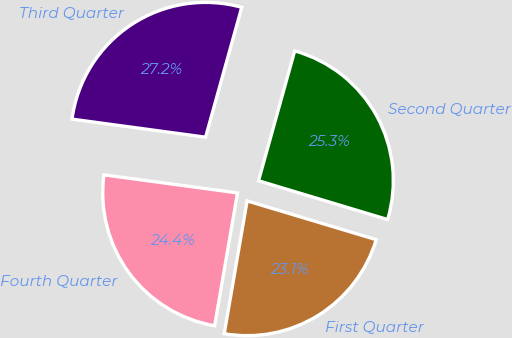<chart> <loc_0><loc_0><loc_500><loc_500><pie_chart><fcel>First Quarter<fcel>Second Quarter<fcel>Third Quarter<fcel>Fourth Quarter<nl><fcel>23.07%<fcel>25.32%<fcel>27.18%<fcel>24.42%<nl></chart> 